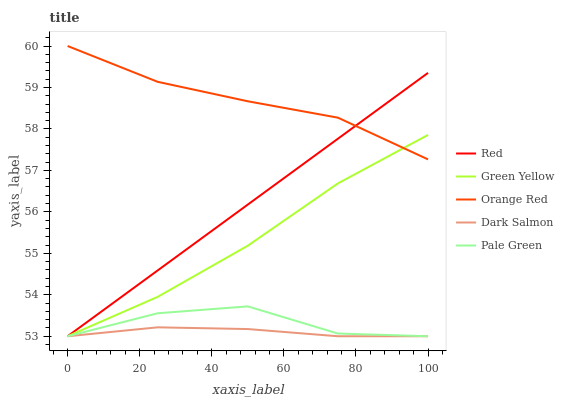Does Dark Salmon have the minimum area under the curve?
Answer yes or no. Yes. Does Orange Red have the maximum area under the curve?
Answer yes or no. Yes. Does Green Yellow have the minimum area under the curve?
Answer yes or no. No. Does Green Yellow have the maximum area under the curve?
Answer yes or no. No. Is Red the smoothest?
Answer yes or no. Yes. Is Pale Green the roughest?
Answer yes or no. Yes. Is Green Yellow the smoothest?
Answer yes or no. No. Is Green Yellow the roughest?
Answer yes or no. No. Does Pale Green have the lowest value?
Answer yes or no. Yes. Does Orange Red have the lowest value?
Answer yes or no. No. Does Orange Red have the highest value?
Answer yes or no. Yes. Does Green Yellow have the highest value?
Answer yes or no. No. Is Dark Salmon less than Orange Red?
Answer yes or no. Yes. Is Orange Red greater than Dark Salmon?
Answer yes or no. Yes. Does Green Yellow intersect Red?
Answer yes or no. Yes. Is Green Yellow less than Red?
Answer yes or no. No. Is Green Yellow greater than Red?
Answer yes or no. No. Does Dark Salmon intersect Orange Red?
Answer yes or no. No. 